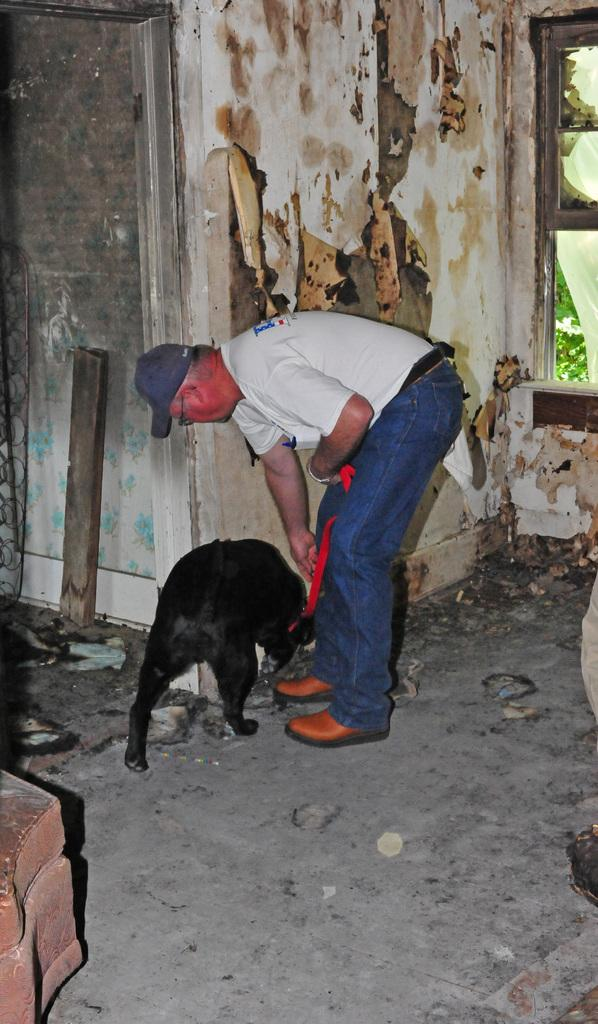Who is present in the image? There is a man in the image. What is the man holding in the image? The man is holding a dog in the image. What can be seen in the background of the image? There is a wall in the background of the image. How many times does the man kiss the dog in the image? There is no indication in the image that the man is kissing the dog, so it cannot be determined from the picture. 